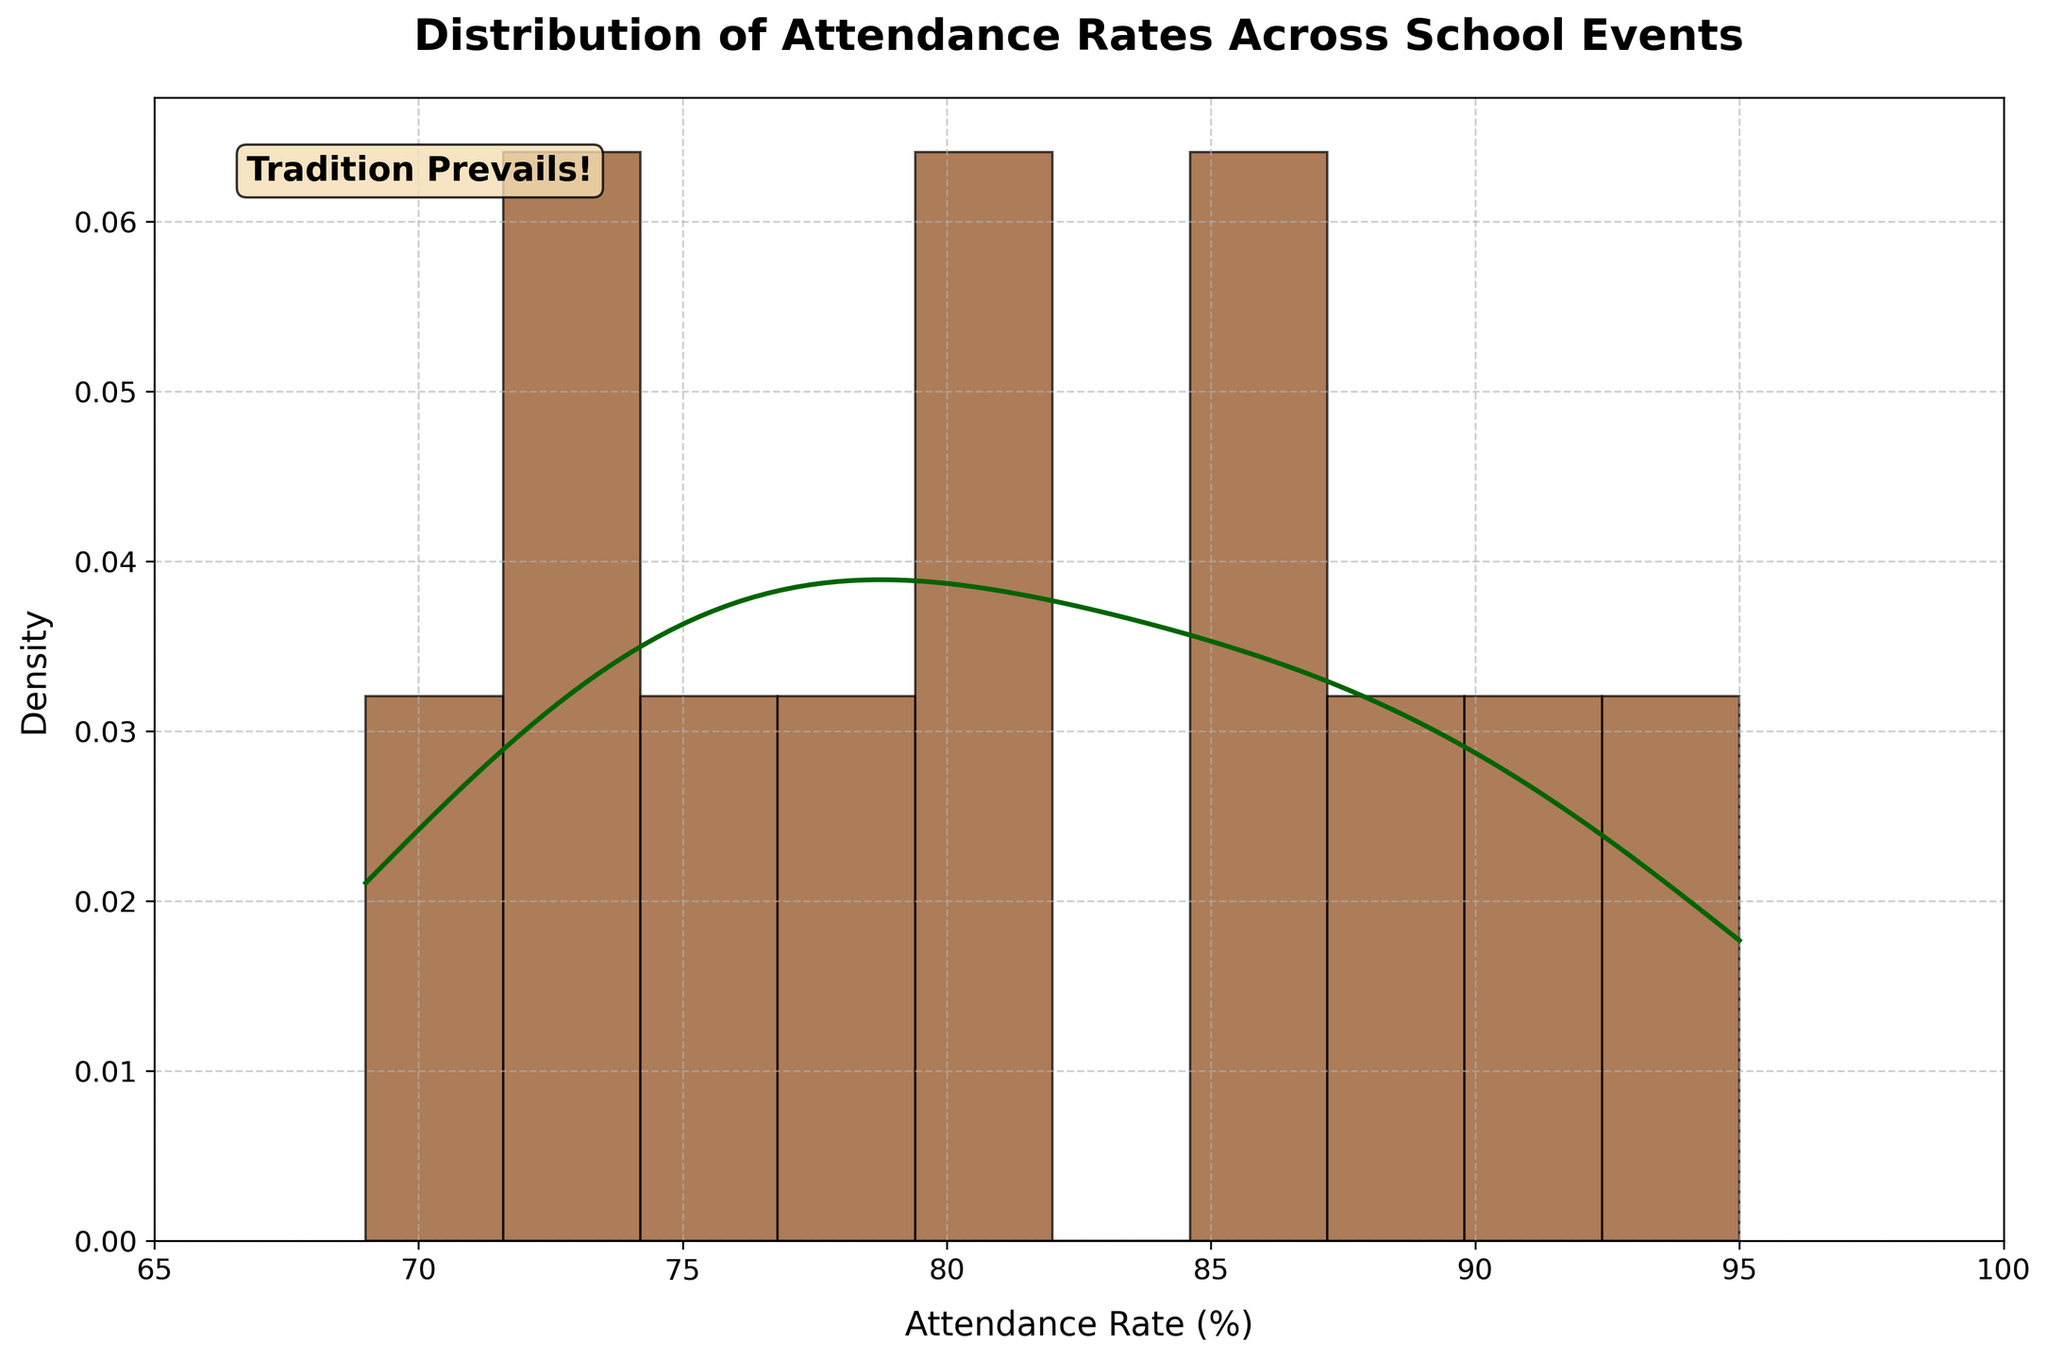What is the title of the figure? The title is displayed at the top center of the figure and serves to give a brief description of the overall plot's subject.
Answer: Distribution of Attendance Rates Across School Events What is the range of attendance rates represented on the x-axis? The x-axis is labeled "Attendance Rate (%)" and its range can be observed at the bottom of the plot.
Answer: 65 to 100 Which color is used for the histogram bars? The histogram bars are filled with a specific color that stands out against the background.
Answer: Brown What type of curve is overlaid on top of the histogram? There is a smooth curve plotted on the histogram to show the distribution's density.
Answer: KDE (Kernel Density Estimation) What is the highest peak of the density curve, and approximately at what attendance rate does it occur? The highest peak of the density curve can be identified by examining the KDE line and observing its maximum point along the x-axis.
Answer: Around 88% What can you infer about the central tendency of attendance rates based on the KDE curve? The central tendency is where the KDE curve peaks, indicating the most common attendance rates in the distribution.
Answer: The central attendance rates tend to cluster around 85% to 95% How does the attendance rate of the "Science Fair" compare to the "Homecoming Dance"? By referring to the event data, compare their attendance rates directly.
Answer: Science Fair: 72%, Homecoming Dance: 92%. The Homecoming Dance has a higher attendance rate What is the median attendance rate, and how can you determine it from the plot? To find the median, identify the midpoint of the sorted attendance rates. Due to the symmetrical nature of the KDE curve, approximate this value as the middle of the x-axis range.
Answer: Approximately 81.5% What is the distribution of attendance rates between club events (Science Fair, Art Show, Math Olympiad) and sports events (Football Game, Basketball Game)? Calculate the mean for each group and compare them. Club events have attendance rates of 72%, 76%, 69%, and sports events have 78%, 80%.
Answer: Club Mean: 72.33%, Sports Mean: 79% What do the annotations in the figure say, and what might be their significance? The text annotations can be seen on the plot and usually provide additional context or emphasis related to the data. Here, it refers to the school's traditional values.
Answer: Tradition Prevails! 